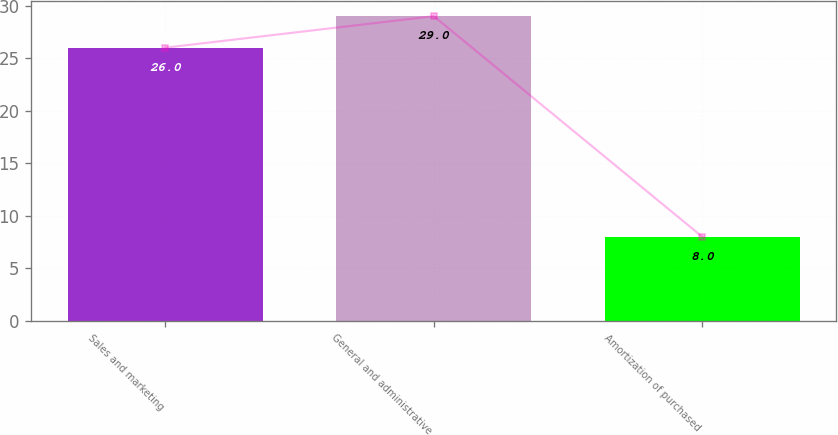Convert chart. <chart><loc_0><loc_0><loc_500><loc_500><bar_chart><fcel>Sales and marketing<fcel>General and administrative<fcel>Amortization of purchased<nl><fcel>26<fcel>29<fcel>8<nl></chart> 